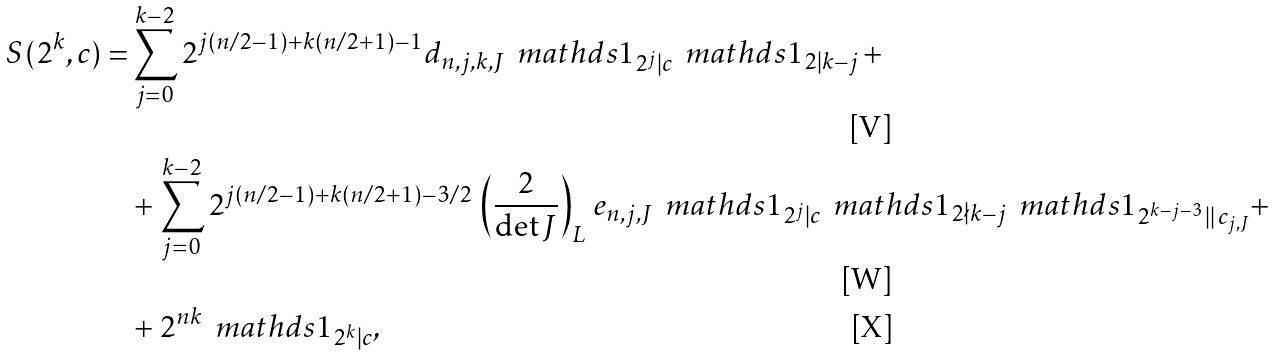<formula> <loc_0><loc_0><loc_500><loc_500>S ( 2 ^ { k } , c ) = & \sum _ { j = 0 } ^ { k - 2 } 2 ^ { j ( n / 2 - 1 ) + k ( n / 2 + 1 ) - 1 } d _ { n , j , k , J } \, \ m a t h d s { 1 } _ { 2 ^ { j } | c } \, \ m a t h d s { 1 } _ { 2 | k - j } \, + \\ & + \sum _ { j = 0 } ^ { k - 2 } 2 ^ { j ( n / 2 - 1 ) + k ( n / 2 + 1 ) - 3 / 2 } \, \left ( \frac { 2 } { \det J } \right ) _ { L } \, e _ { n , j , J } \, \ m a t h d s { 1 } _ { 2 ^ { j } | c } \, \ m a t h d s { 1 } _ { 2 \nmid k - j } \, \ m a t h d s { 1 } _ { 2 ^ { k - j - 3 } \, | | \, c _ { j , J } } + \\ & + 2 ^ { n k } \, \ m a t h d s { 1 } _ { 2 ^ { k } | c } ,</formula> 